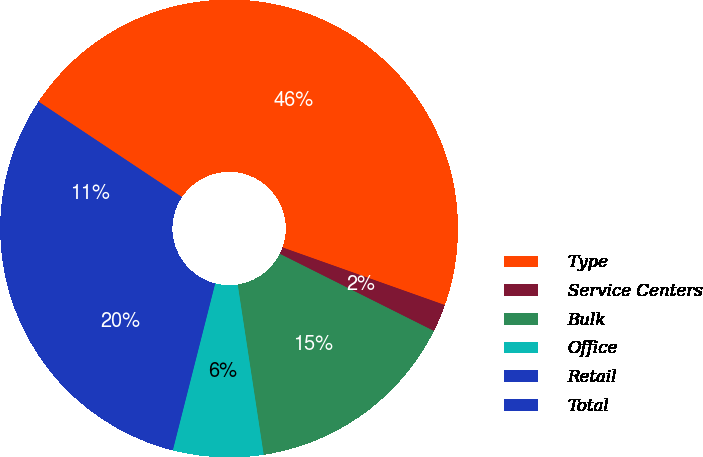<chart> <loc_0><loc_0><loc_500><loc_500><pie_chart><fcel>Type<fcel>Service Centers<fcel>Bulk<fcel>Office<fcel>Retail<fcel>Total<nl><fcel>46.08%<fcel>1.96%<fcel>15.2%<fcel>6.37%<fcel>19.61%<fcel>10.78%<nl></chart> 